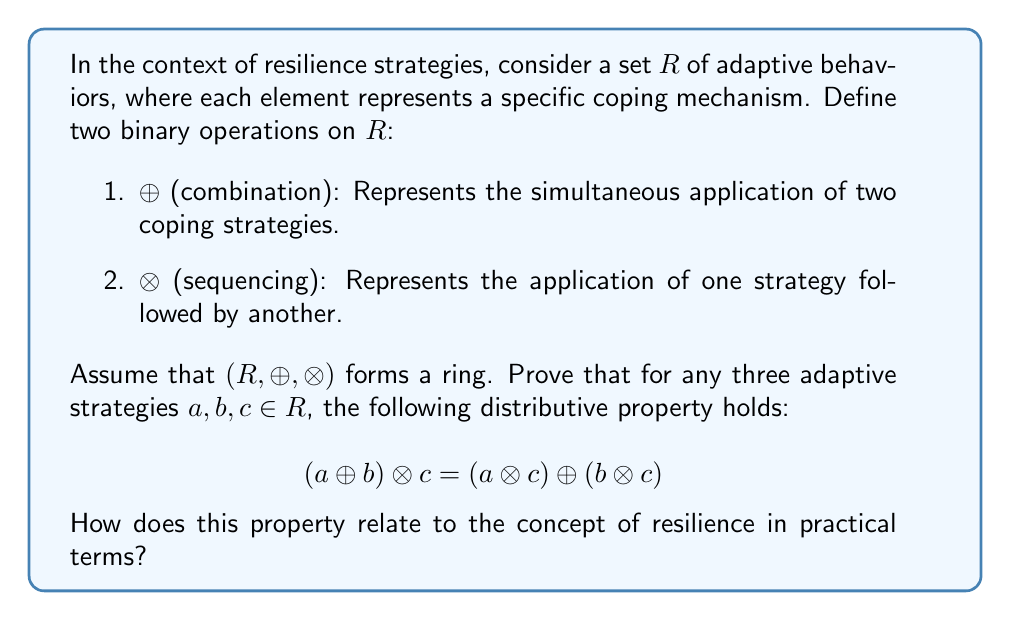Can you answer this question? To prove the distributive property in the ring $(R, \oplus, \otimes)$, we can use the axioms of ring theory:

1. Closure: For all $a, b \in R$, $a \oplus b$ and $a \otimes b$ are in $R$.
2. Associativity: For all $a, b, c \in R$, $(a \oplus b) \oplus c = a \oplus (b \oplus c)$ and $(a \otimes b) \otimes c = a \otimes (b \otimes c)$.
3. Commutativity of addition: For all $a, b \in R$, $a \oplus b = b \oplus a$.
4. Additive identity: There exists an element $0 \in R$ such that $a \oplus 0 = a$ for all $a \in R$.
5. Additive inverses: For each $a \in R$, there exists $-a \in R$ such that $a \oplus (-a) = 0$.
6. Distributive property: For all $a, b, c \in R$, $(a \oplus b) \otimes c = (a \otimes c) \oplus (b \otimes c)$ and $c \otimes (a \oplus b) = (c \otimes a) \oplus (c \otimes b)$.

The distributive property is given as an axiom in the definition of a ring, so it automatically holds for $(R, \oplus, \otimes)$. However, we can interpret this property in the context of resilience strategies:

1. $(a \oplus b)$ represents the combination of two adaptive strategies.
2. $((a \oplus b) \otimes c)$ means applying strategy $c$ after the combined strategies $a$ and $b$.
3. $(a \otimes c) \oplus (b \otimes c)$ means applying strategy $c$ after $a$, and separately applying $c$ after $b$, then combining these results.

The equality of these expressions implies that in resilience training, the order of combining and sequencing strategies doesn't affect the final outcome. This property is crucial for developing flexible and adaptive resilience strategies, as it allows for the interchangeable application of coping mechanisms without altering the overall effectiveness of the approach.

In practical terms, this property relates to resilience by demonstrating that:

1. Flexibility in strategy application is possible without compromising effectiveness.
2. Complex resilience strategies can be broken down into simpler components.
3. Different paths to combining and sequencing coping mechanisms can lead to the same result, allowing for personalized approaches.
4. The systematic nature of resilience strategies can be studied and optimized using algebraic principles.
Answer: The distributive property $(a \oplus b) \otimes c = (a \otimes c) \oplus (b \otimes c)$ holds in the ring $(R, \oplus, \otimes)$ of adaptive strategies. This property demonstrates that the order of combining and sequencing resilience strategies does not affect the final outcome, allowing for flexible and personalized approaches in resilience training. 